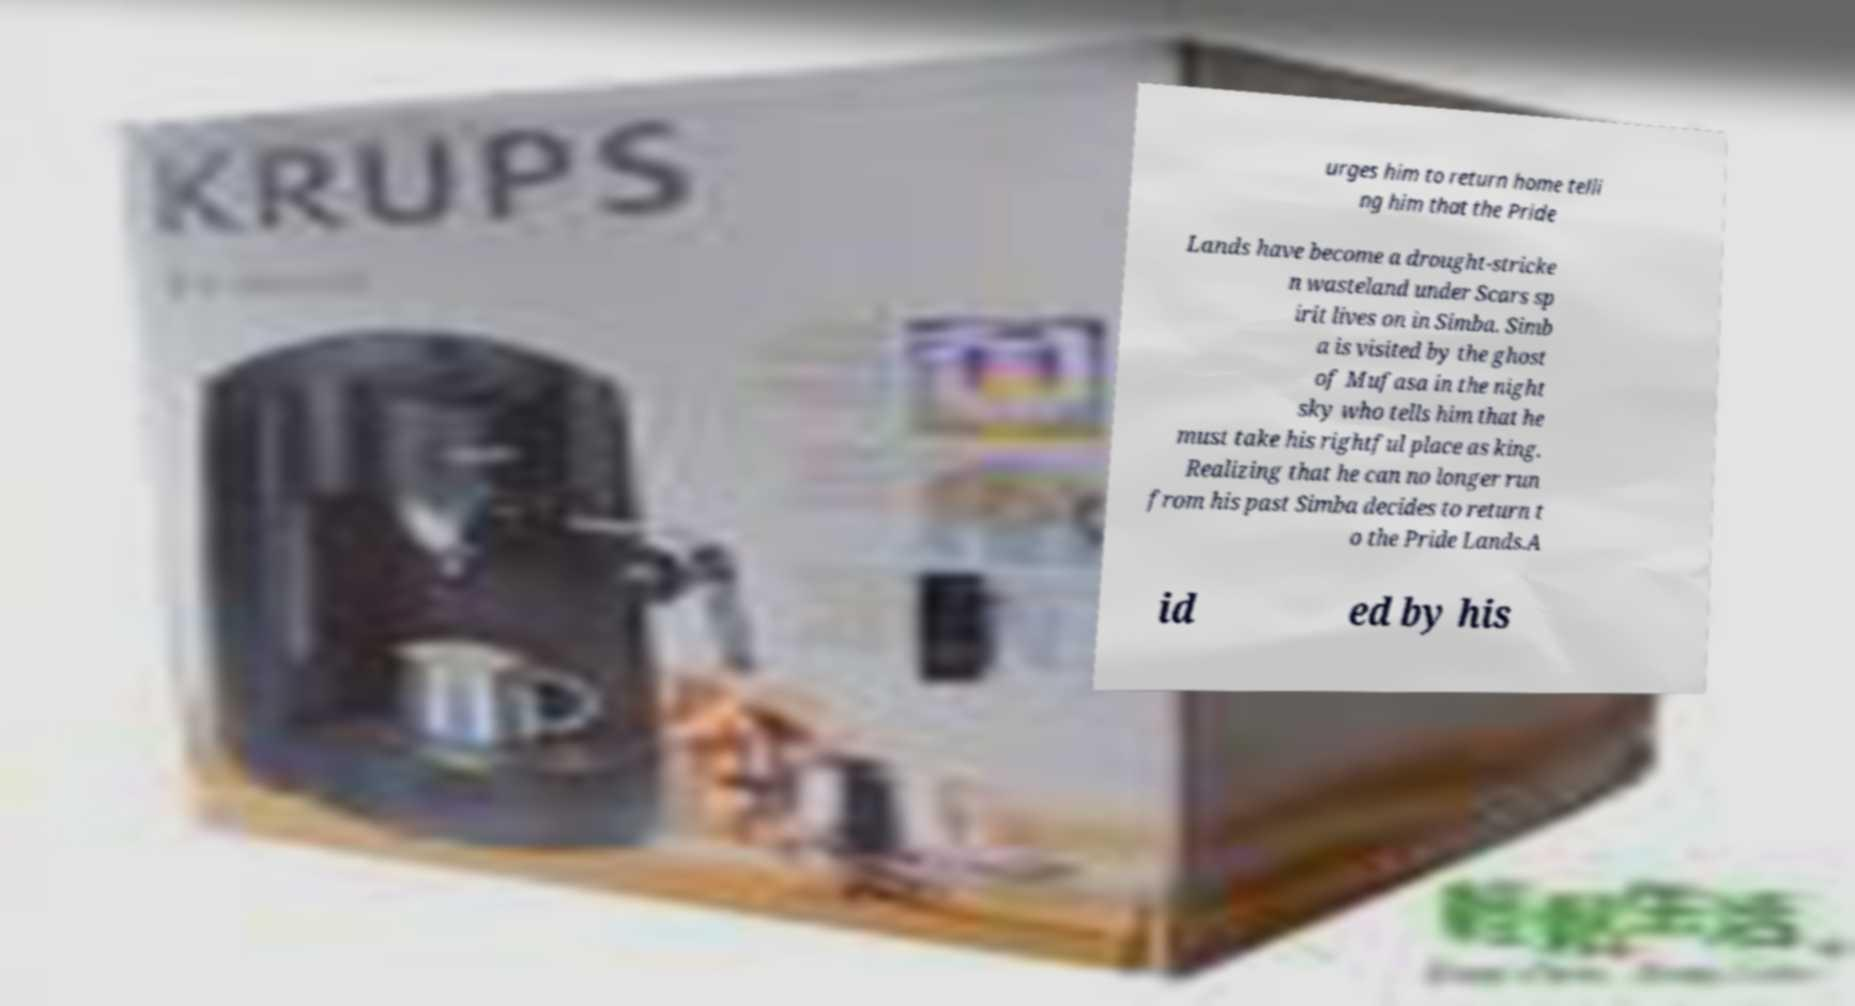Please read and relay the text visible in this image. What does it say? urges him to return home telli ng him that the Pride Lands have become a drought-stricke n wasteland under Scars sp irit lives on in Simba. Simb a is visited by the ghost of Mufasa in the night sky who tells him that he must take his rightful place as king. Realizing that he can no longer run from his past Simba decides to return t o the Pride Lands.A id ed by his 